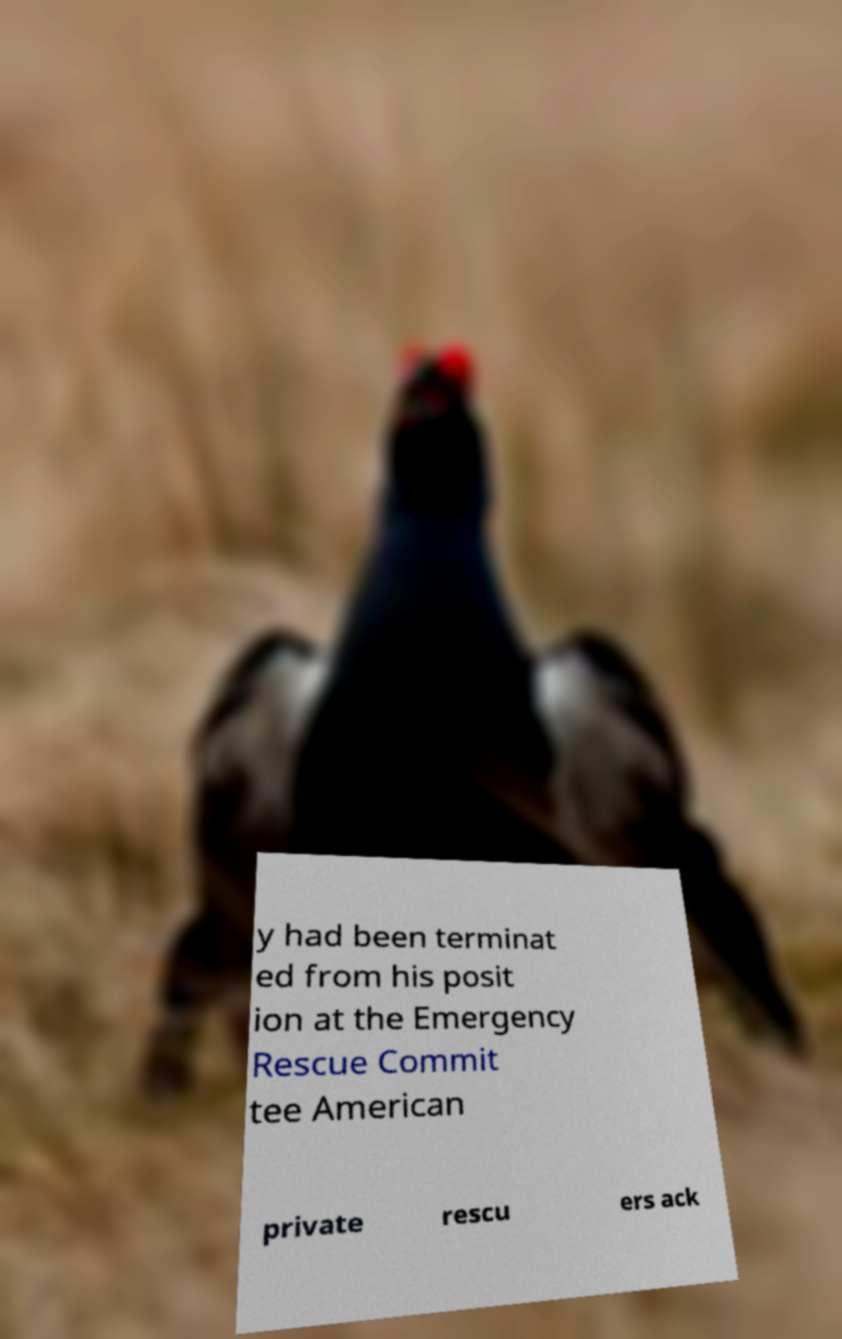What messages or text are displayed in this image? I need them in a readable, typed format. y had been terminat ed from his posit ion at the Emergency Rescue Commit tee American private rescu ers ack 